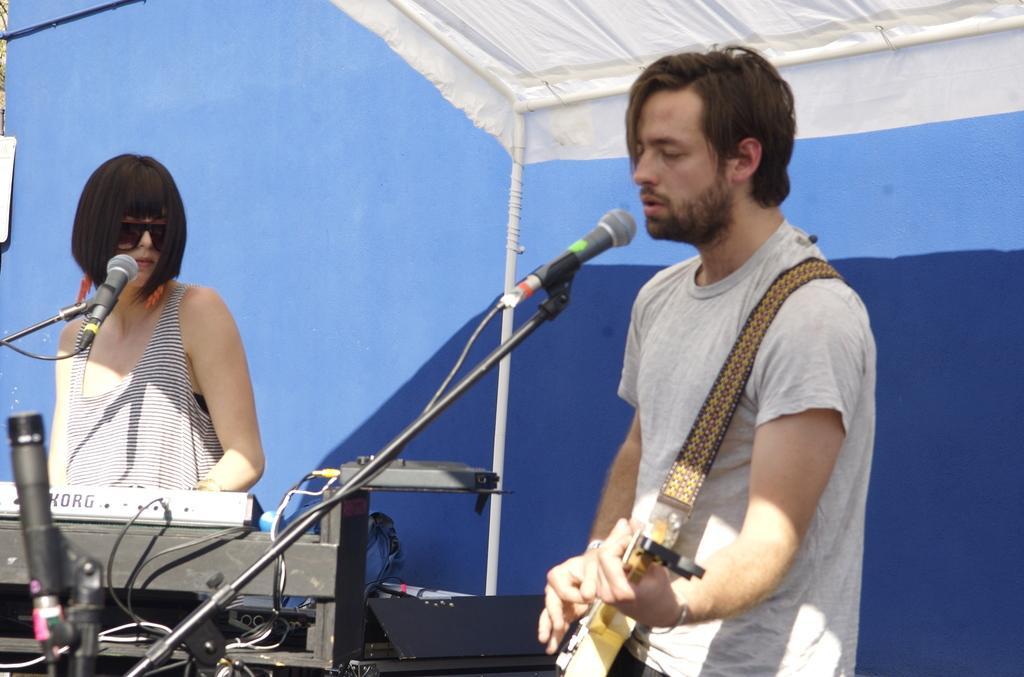Could you give a brief overview of what you see in this image? There are two people standing. Woman is playing piano and men is playing guitar. He is singing a song. These are the mics attached to the mike stand. Here I can see a black color object. This is a white color cloth at the top,background looks blue in color. 